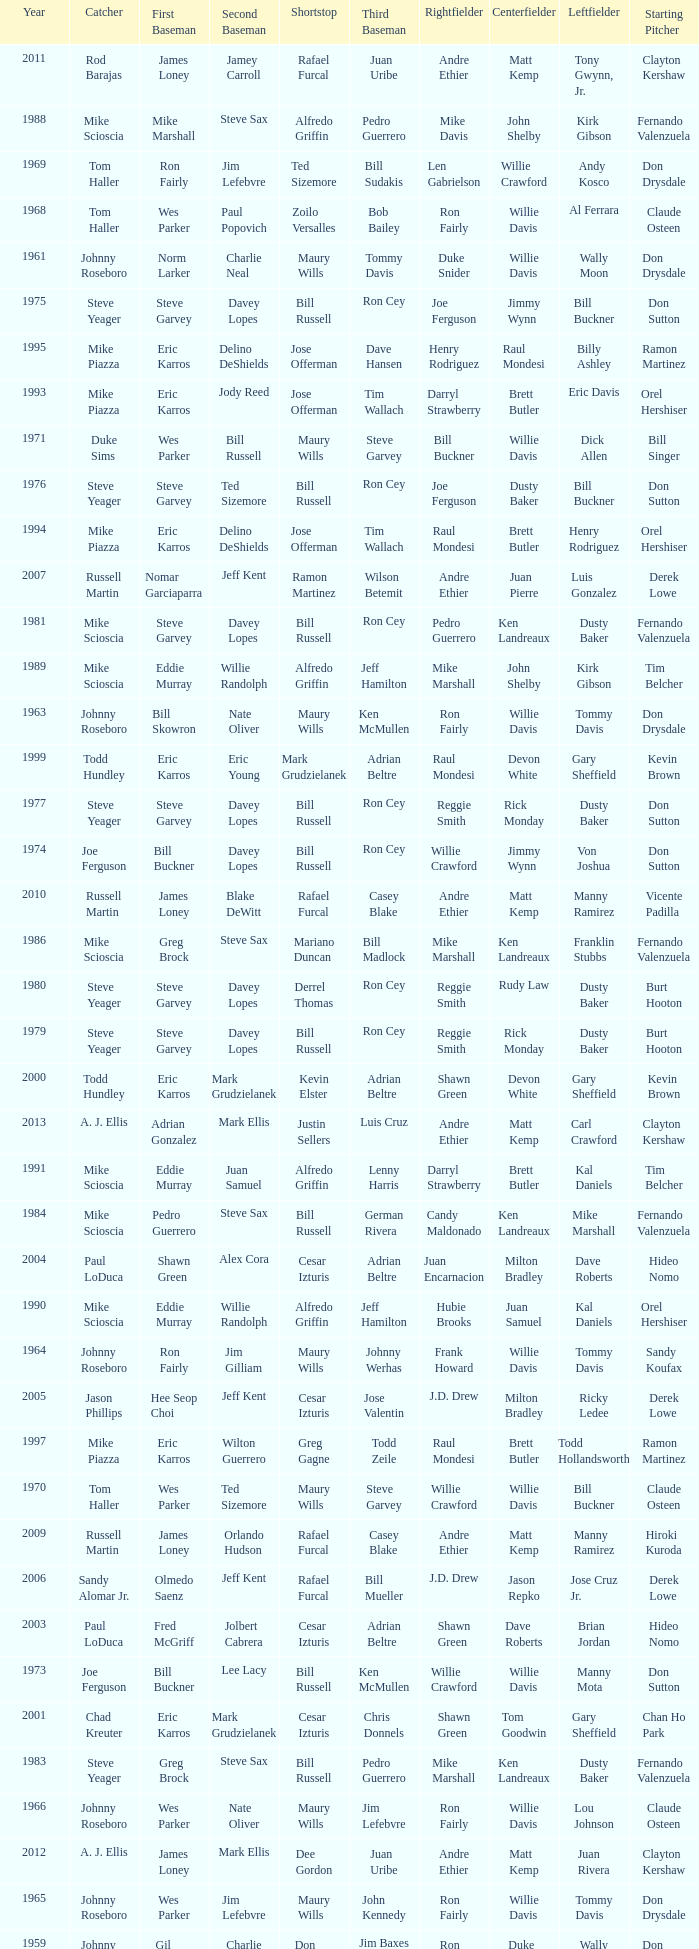Can you give me this table as a dict? {'header': ['Year', 'Catcher', 'First Baseman', 'Second Baseman', 'Shortstop', 'Third Baseman', 'Rightfielder', 'Centerfielder', 'Leftfielder', 'Starting Pitcher'], 'rows': [['2011', 'Rod Barajas', 'James Loney', 'Jamey Carroll', 'Rafael Furcal', 'Juan Uribe', 'Andre Ethier', 'Matt Kemp', 'Tony Gwynn, Jr.', 'Clayton Kershaw'], ['1988', 'Mike Scioscia', 'Mike Marshall', 'Steve Sax', 'Alfredo Griffin', 'Pedro Guerrero', 'Mike Davis', 'John Shelby', 'Kirk Gibson', 'Fernando Valenzuela'], ['1969', 'Tom Haller', 'Ron Fairly', 'Jim Lefebvre', 'Ted Sizemore', 'Bill Sudakis', 'Len Gabrielson', 'Willie Crawford', 'Andy Kosco', 'Don Drysdale'], ['1968', 'Tom Haller', 'Wes Parker', 'Paul Popovich', 'Zoilo Versalles', 'Bob Bailey', 'Ron Fairly', 'Willie Davis', 'Al Ferrara', 'Claude Osteen'], ['1961', 'Johnny Roseboro', 'Norm Larker', 'Charlie Neal', 'Maury Wills', 'Tommy Davis', 'Duke Snider', 'Willie Davis', 'Wally Moon', 'Don Drysdale'], ['1975', 'Steve Yeager', 'Steve Garvey', 'Davey Lopes', 'Bill Russell', 'Ron Cey', 'Joe Ferguson', 'Jimmy Wynn', 'Bill Buckner', 'Don Sutton'], ['1995', 'Mike Piazza', 'Eric Karros', 'Delino DeShields', 'Jose Offerman', 'Dave Hansen', 'Henry Rodriguez', 'Raul Mondesi', 'Billy Ashley', 'Ramon Martinez'], ['1993', 'Mike Piazza', 'Eric Karros', 'Jody Reed', 'Jose Offerman', 'Tim Wallach', 'Darryl Strawberry', 'Brett Butler', 'Eric Davis', 'Orel Hershiser'], ['1971', 'Duke Sims', 'Wes Parker', 'Bill Russell', 'Maury Wills', 'Steve Garvey', 'Bill Buckner', 'Willie Davis', 'Dick Allen', 'Bill Singer'], ['1976', 'Steve Yeager', 'Steve Garvey', 'Ted Sizemore', 'Bill Russell', 'Ron Cey', 'Joe Ferguson', 'Dusty Baker', 'Bill Buckner', 'Don Sutton'], ['1994', 'Mike Piazza', 'Eric Karros', 'Delino DeShields', 'Jose Offerman', 'Tim Wallach', 'Raul Mondesi', 'Brett Butler', 'Henry Rodriguez', 'Orel Hershiser'], ['2007', 'Russell Martin', 'Nomar Garciaparra', 'Jeff Kent', 'Ramon Martinez', 'Wilson Betemit', 'Andre Ethier', 'Juan Pierre', 'Luis Gonzalez', 'Derek Lowe'], ['1981', 'Mike Scioscia', 'Steve Garvey', 'Davey Lopes', 'Bill Russell', 'Ron Cey', 'Pedro Guerrero', 'Ken Landreaux', 'Dusty Baker', 'Fernando Valenzuela'], ['1989', 'Mike Scioscia', 'Eddie Murray', 'Willie Randolph', 'Alfredo Griffin', 'Jeff Hamilton', 'Mike Marshall', 'John Shelby', 'Kirk Gibson', 'Tim Belcher'], ['1963', 'Johnny Roseboro', 'Bill Skowron', 'Nate Oliver', 'Maury Wills', 'Ken McMullen', 'Ron Fairly', 'Willie Davis', 'Tommy Davis', 'Don Drysdale'], ['1999', 'Todd Hundley', 'Eric Karros', 'Eric Young', 'Mark Grudzielanek', 'Adrian Beltre', 'Raul Mondesi', 'Devon White', 'Gary Sheffield', 'Kevin Brown'], ['1977', 'Steve Yeager', 'Steve Garvey', 'Davey Lopes', 'Bill Russell', 'Ron Cey', 'Reggie Smith', 'Rick Monday', 'Dusty Baker', 'Don Sutton'], ['1974', 'Joe Ferguson', 'Bill Buckner', 'Davey Lopes', 'Bill Russell', 'Ron Cey', 'Willie Crawford', 'Jimmy Wynn', 'Von Joshua', 'Don Sutton'], ['2010', 'Russell Martin', 'James Loney', 'Blake DeWitt', 'Rafael Furcal', 'Casey Blake', 'Andre Ethier', 'Matt Kemp', 'Manny Ramirez', 'Vicente Padilla'], ['1986', 'Mike Scioscia', 'Greg Brock', 'Steve Sax', 'Mariano Duncan', 'Bill Madlock', 'Mike Marshall', 'Ken Landreaux', 'Franklin Stubbs', 'Fernando Valenzuela'], ['1980', 'Steve Yeager', 'Steve Garvey', 'Davey Lopes', 'Derrel Thomas', 'Ron Cey', 'Reggie Smith', 'Rudy Law', 'Dusty Baker', 'Burt Hooton'], ['1979', 'Steve Yeager', 'Steve Garvey', 'Davey Lopes', 'Bill Russell', 'Ron Cey', 'Reggie Smith', 'Rick Monday', 'Dusty Baker', 'Burt Hooton'], ['2000', 'Todd Hundley', 'Eric Karros', 'Mark Grudzielanek', 'Kevin Elster', 'Adrian Beltre', 'Shawn Green', 'Devon White', 'Gary Sheffield', 'Kevin Brown'], ['2013', 'A. J. Ellis', 'Adrian Gonzalez', 'Mark Ellis', 'Justin Sellers', 'Luis Cruz', 'Andre Ethier', 'Matt Kemp', 'Carl Crawford', 'Clayton Kershaw'], ['1991', 'Mike Scioscia', 'Eddie Murray', 'Juan Samuel', 'Alfredo Griffin', 'Lenny Harris', 'Darryl Strawberry', 'Brett Butler', 'Kal Daniels', 'Tim Belcher'], ['1984', 'Mike Scioscia', 'Pedro Guerrero', 'Steve Sax', 'Bill Russell', 'German Rivera', 'Candy Maldonado', 'Ken Landreaux', 'Mike Marshall', 'Fernando Valenzuela'], ['2004', 'Paul LoDuca', 'Shawn Green', 'Alex Cora', 'Cesar Izturis', 'Adrian Beltre', 'Juan Encarnacion', 'Milton Bradley', 'Dave Roberts', 'Hideo Nomo'], ['1990', 'Mike Scioscia', 'Eddie Murray', 'Willie Randolph', 'Alfredo Griffin', 'Jeff Hamilton', 'Hubie Brooks', 'Juan Samuel', 'Kal Daniels', 'Orel Hershiser'], ['1964', 'Johnny Roseboro', 'Ron Fairly', 'Jim Gilliam', 'Maury Wills', 'Johnny Werhas', 'Frank Howard', 'Willie Davis', 'Tommy Davis', 'Sandy Koufax'], ['2005', 'Jason Phillips', 'Hee Seop Choi', 'Jeff Kent', 'Cesar Izturis', 'Jose Valentin', 'J.D. Drew', 'Milton Bradley', 'Ricky Ledee', 'Derek Lowe'], ['1997', 'Mike Piazza', 'Eric Karros', 'Wilton Guerrero', 'Greg Gagne', 'Todd Zeile', 'Raul Mondesi', 'Brett Butler', 'Todd Hollandsworth', 'Ramon Martinez'], ['1970', 'Tom Haller', 'Wes Parker', 'Ted Sizemore', 'Maury Wills', 'Steve Garvey', 'Willie Crawford', 'Willie Davis', 'Bill Buckner', 'Claude Osteen'], ['2009', 'Russell Martin', 'James Loney', 'Orlando Hudson', 'Rafael Furcal', 'Casey Blake', 'Andre Ethier', 'Matt Kemp', 'Manny Ramirez', 'Hiroki Kuroda'], ['2006', 'Sandy Alomar Jr.', 'Olmedo Saenz', 'Jeff Kent', 'Rafael Furcal', 'Bill Mueller', 'J.D. Drew', 'Jason Repko', 'Jose Cruz Jr.', 'Derek Lowe'], ['2003', 'Paul LoDuca', 'Fred McGriff', 'Jolbert Cabrera', 'Cesar Izturis', 'Adrian Beltre', 'Shawn Green', 'Dave Roberts', 'Brian Jordan', 'Hideo Nomo'], ['1973', 'Joe Ferguson', 'Bill Buckner', 'Lee Lacy', 'Bill Russell', 'Ken McMullen', 'Willie Crawford', 'Willie Davis', 'Manny Mota', 'Don Sutton'], ['2001', 'Chad Kreuter', 'Eric Karros', 'Mark Grudzielanek', 'Cesar Izturis', 'Chris Donnels', 'Shawn Green', 'Tom Goodwin', 'Gary Sheffield', 'Chan Ho Park'], ['1983', 'Steve Yeager', 'Greg Brock', 'Steve Sax', 'Bill Russell', 'Pedro Guerrero', 'Mike Marshall', 'Ken Landreaux', 'Dusty Baker', 'Fernando Valenzuela'], ['1966', 'Johnny Roseboro', 'Wes Parker', 'Nate Oliver', 'Maury Wills', 'Jim Lefebvre', 'Ron Fairly', 'Willie Davis', 'Lou Johnson', 'Claude Osteen'], ['2012', 'A. J. Ellis', 'James Loney', 'Mark Ellis', 'Dee Gordon', 'Juan Uribe', 'Andre Ethier', 'Matt Kemp', 'Juan Rivera', 'Clayton Kershaw'], ['1965', 'Johnny Roseboro', 'Wes Parker', 'Jim Lefebvre', 'Maury Wills', 'John Kennedy', 'Ron Fairly', 'Willie Davis', 'Tommy Davis', 'Don Drysdale'], ['1959', 'Johnny Roseboro', 'Gil Hodges', 'Charlie Neal', 'Don Zimmer', 'Jim Baxes', 'Ron Fairly', 'Duke Snider', 'Wally Moon', 'Don Drysdale'], ['1996', 'Mike Piazza', 'Eric Karros', 'Delino DeShields', 'Greg Gagne', 'Mike Blowers', 'Raul Mondesi', 'Brett Butler', 'Todd Hollandsworth', 'Ramon Martinez'], ['2008', 'Russell Martin', 'James Loney', 'Jeff Kent', 'Rafael Furcal', 'Blake DeWitt', 'Matt Kemp', 'Andruw Jones', 'Andre Ethier', 'Brad Penny'], ['1982', 'Steve Yeager', 'Steve Garvey', 'Steve Sax', 'Bill Russell', 'Ron Cey', 'Pedro Guerrero', 'Ken Landreaux', 'Dusty Baker', 'Jerry Reuss'], ['1972', 'Duke Sims', 'Bill Buckner', 'Jim Lefebvre', 'Maury Wills', 'Billy Grabarkewitz', 'Frank Robinson', 'Willie Davis', 'Willie Crawford', 'Don Sutton'], ['1992', 'Mike Scioscia', 'Kal Daniels', 'Juan Samuel', 'Jose Offerman', 'Lenny Harris', 'Darryl Strawberry', 'Brett Butler', 'Eric Davis', 'Ramon Martinez'], ['1962', 'Johnny Roseboro', 'Ron Fairly', 'Jim Gilliam', 'Maury Wills', 'Daryl Spencer', 'Duke Snider', 'Willie Davis', 'Wally Moon', 'Johnny Podres'], ['2002', 'Paul LoDuca', 'Eric Karros', 'Mark Grudzielanek', 'Cesar Izturis', 'Adrian Beltre', 'Shawn Green', 'Dave Roberts', 'Brian Jordan', 'Kevin Brown'], ['1978', 'Steve Yeager', 'Steve Garvey', 'Davey Lopes', 'Bill Russell', 'Ron Cey', 'Reggie Smith', 'Rick Monday', 'Dusty Baker', 'Don Sutton'], ['1985', 'Mike Scioscia', 'Sid Bream', 'Mariano Duncan', 'Dave Anderson', 'Pedro Guerrero', 'Mike Marshall', 'Ken Landreaux', 'Al Oliver', 'Fernando Valenzuela'], ['1987', 'Mike Scioscia', 'Franklin Stubbs', 'Steve Sax', 'Mariano Duncan', 'Bill Madlock', 'Mike Marshall', 'Mike Ramsey', 'Ken Landreaux', 'Orel Hershiser'], ['1960', 'Johnny Roseboro', 'Gil Hodges', 'Charlie Neal', 'Maury Wills', 'Jim Gilliam', 'Duke Snider', 'Don Demeter', 'Wally Moon', 'Don Drysdale'], ['1967', 'Johnny Roseboro', 'Ron Fairly', 'Ron Hunt', 'Gene Michael', 'Jim Lefebvre', 'Lou Johnson', 'Wes Parker', 'Bob Bailey', 'Bob Miller'], ['1998', 'Mike Piazza', 'Paul Konerko', 'Eric Young', 'Jose Vizcaino', 'Todd Zeile', 'Raul Mondesi', 'Trenidad Hubbard', 'Todd Hollandsworth', 'Ramon Martinez']]} Who played 2nd base when nomar garciaparra was at 1st base? Jeff Kent. 